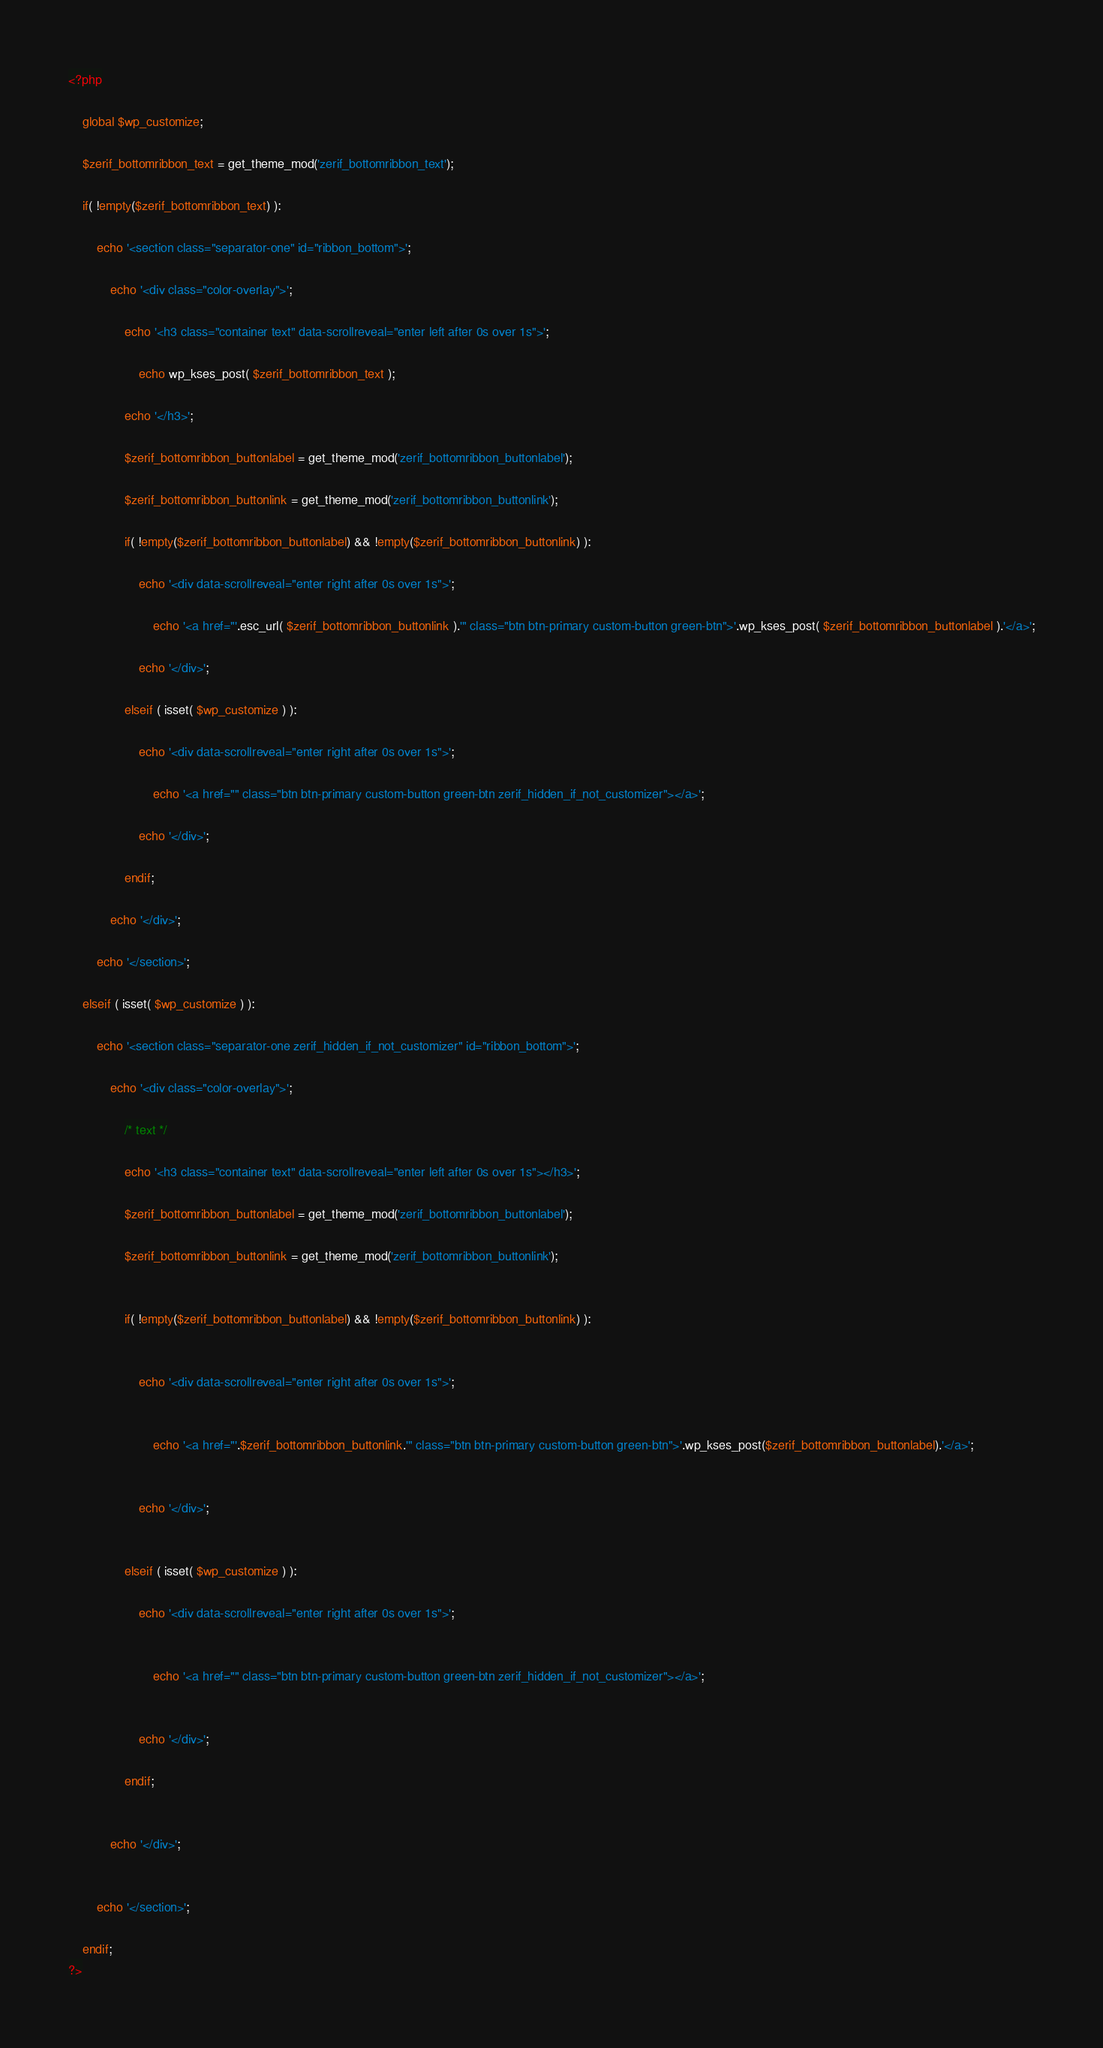Convert code to text. <code><loc_0><loc_0><loc_500><loc_500><_PHP_><?php	global $wp_customize;	$zerif_bottomribbon_text = get_theme_mod('zerif_bottomribbon_text');	if( !empty($zerif_bottomribbon_text) ):		echo '<section class="separator-one" id="ribbon_bottom">';			echo '<div class="color-overlay">';				echo '<h3 class="container text" data-scrollreveal="enter left after 0s over 1s">';					echo wp_kses_post( $zerif_bottomribbon_text );				echo '</h3>';				$zerif_bottomribbon_buttonlabel = get_theme_mod('zerif_bottomribbon_buttonlabel');				$zerif_bottomribbon_buttonlink = get_theme_mod('zerif_bottomribbon_buttonlink');				if( !empty($zerif_bottomribbon_buttonlabel) && !empty($zerif_bottomribbon_buttonlink) ):					echo '<div data-scrollreveal="enter right after 0s over 1s">';						echo '<a href="'.esc_url( $zerif_bottomribbon_buttonlink ).'" class="btn btn-primary custom-button green-btn">'.wp_kses_post( $zerif_bottomribbon_buttonlabel ).'</a>';					echo '</div>';				elseif ( isset( $wp_customize ) ):									echo '<div data-scrollreveal="enter right after 0s over 1s">';						echo '<a href="" class="btn btn-primary custom-button green-btn zerif_hidden_if_not_customizer"></a>';					echo '</div>';								endif;			echo '</div>';		echo '</section>';		elseif ( isset( $wp_customize ) ):				echo '<section class="separator-one zerif_hidden_if_not_customizer" id="ribbon_bottom">';			echo '<div class="color-overlay">';				/* text */							echo '<h3 class="container text" data-scrollreveal="enter left after 0s over 1s"></h3>';				$zerif_bottomribbon_buttonlabel = get_theme_mod('zerif_bottomribbon_buttonlabel');				$zerif_bottomribbon_buttonlink = get_theme_mod('zerif_bottomribbon_buttonlink');				if( !empty($zerif_bottomribbon_buttonlabel) && !empty($zerif_bottomribbon_buttonlink) ):					echo '<div data-scrollreveal="enter right after 0s over 1s">';						echo '<a href="'.$zerif_bottomribbon_buttonlink.'" class="btn btn-primary custom-button green-btn">'.wp_kses_post($zerif_bottomribbon_buttonlabel).'</a>';					echo '</div>';				elseif ( isset( $wp_customize ) ):									echo '<div data-scrollreveal="enter right after 0s over 1s">';						echo '<a href="" class="btn btn-primary custom-button green-btn zerif_hidden_if_not_customizer"></a>';					echo '</div>';								endif;			echo '</div>';		echo '</section>';			endif;?></code> 